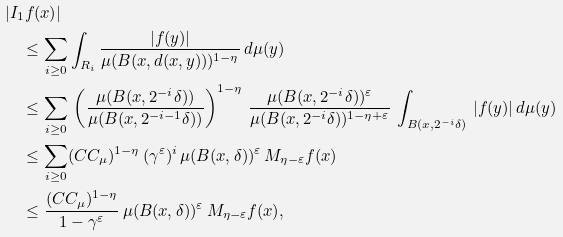Convert formula to latex. <formula><loc_0><loc_0><loc_500><loc_500>& | I _ { 1 } f ( x ) | \\ & \quad \leq \sum _ { i \geq 0 } \int _ { R _ { i } } \frac { | f ( y ) | } { \mu ( B ( x , d ( x , y ) ) ) ^ { 1 - \eta } } \, d \mu ( y ) \\ & \quad \leq \underset { i \geq 0 } { \sum } \, \left ( \frac { \mu ( B ( x , 2 ^ { - i } \delta ) ) } { \mu ( B ( x , 2 ^ { - i - 1 } \delta ) ) } \right ) ^ { 1 - \eta } \, \frac { \mu ( B ( x , 2 ^ { - i } \delta ) ) ^ { \varepsilon } } { \mu ( B ( x , 2 ^ { - i } \delta ) ) ^ { 1 - \eta + \varepsilon } } \, \int _ { B ( x , 2 ^ { - i } \delta ) } \, | f ( y ) | \, d \mu ( y ) \\ & \quad \leq \underset { i \geq 0 } { \sum } ( C C _ { \mu } ) ^ { 1 - \eta } \, ( \gamma ^ { \varepsilon } ) ^ { i } \, \mu ( B ( x , \delta ) ) ^ { \varepsilon } \, M _ { \eta - \varepsilon } f ( x ) \\ & \quad \leq \frac { ( C C _ { \mu } ) ^ { 1 - \eta } } { 1 - \gamma ^ { \varepsilon } } \, \mu ( B ( x , \delta ) ) ^ { \varepsilon } \, M _ { \eta - \varepsilon } f ( x ) ,</formula> 